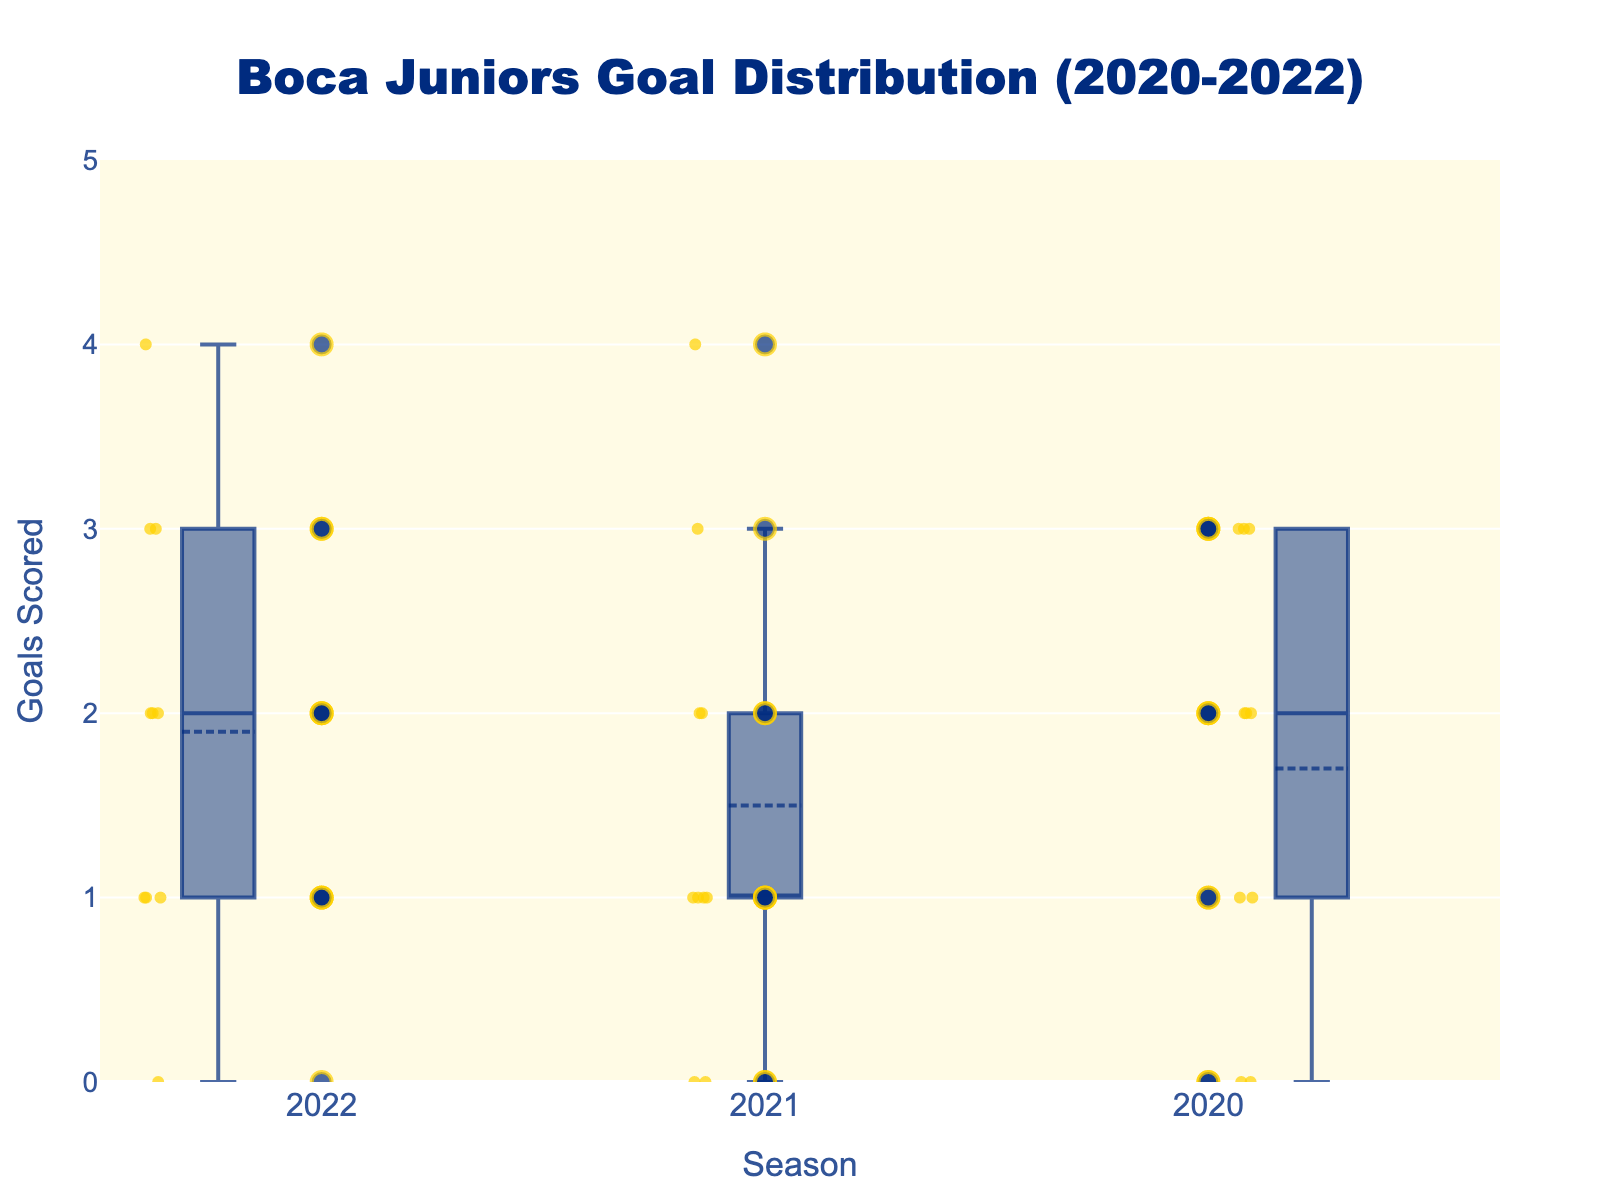Who scored the most goals in a single match for Boca Juniors in the 2022 season? Based on the scatter points in the 2022 season box plot, Boca Juniors scored 4 goals in a match, which is the highest single match goal.
Answer: 4 Which season has the highest median number of goals? Observe the central line within each box plot, which indicates the median. The 2021 season has the highest median, where the line is at 2 goals.
Answer: 2021 How many matches in the 2020 season did Boca Juniors score no goals? Look at the scatter points on the 2020 season box plot. There are 2 points at 0, indicating 2 matches with no goals.
Answer: 2 What is the interquartile range (IQR) of goals scored by Boca Juniors in the 2021 season? The IQR is obtained by subtracting the first quartile (Q1, the bottom of the box) from the third quartile (Q3, the top of the box). For the 2021 season, Q3 is at 3 and Q1 is at 1, so IQR = 3 - 1 = 2.
Answer: 2 In which season did Boca Juniors have the most consistent goal scoring (least spread)? The spread is indicated by the length of the box plot's whiskers. The 2021 season box plot has the shortest whiskers, showing least spread.
Answer: 2021 How does the average number of goals in the 2022 season compare to the 2020 season? Find the mean by averaging the scatter points (individual scores) for each season. The 2022 season's average appears higher as 3 goals are frequent, while in 2020, the spread is more even with some higher points but also frequent low scores.
Answer: 2022 has a higher average Which season shows the greatest variability in goals scored by Boca Juniors? Variability is indicated by the overall spread (range from minimum to maximum) within the box plot. The 2020 season has the widest spread, indicating the greatest variability.
Answer: 2020 What is the median number of goals Boca Juniors scored in the 2020 season? The median is the central line in the box plot. In the 2020 season, this line is at 2 goals.
Answer: 2 How many matches did Boca Juniors play each season as per the scatter points on the plot? Count the number of scatter points for each season, which represent the matches. There are 10 matches shown for each of the 2020, 2021, and 2022 seasons.
Answer: 10 per season 